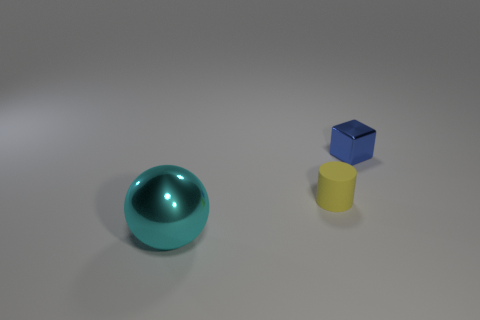There is a shiny object to the left of the yellow object; is it the same shape as the tiny thing that is in front of the blue metallic thing?
Your response must be concise. No. What is the material of the big thing?
Offer a terse response. Metal. What number of yellow things have the same size as the cube?
Your answer should be very brief. 1. How many things are either metallic objects in front of the small blue metallic block or things that are behind the large cyan sphere?
Keep it short and to the point. 3. Does the tiny object that is in front of the tiny blue shiny block have the same material as the object behind the small cylinder?
Offer a terse response. No. What is the shape of the tiny thing to the right of the tiny thing that is in front of the blue cube?
Keep it short and to the point. Cube. Is there any other thing that has the same color as the big metal object?
Offer a terse response. No. Is there a shiny cube that is behind the metallic object behind the small thing that is on the left side of the blue object?
Give a very brief answer. No. There is a tiny thing that is in front of the tiny cube; is it the same color as the shiny object that is to the left of the metallic cube?
Ensure brevity in your answer.  No. What material is the object that is the same size as the yellow rubber cylinder?
Ensure brevity in your answer.  Metal. 